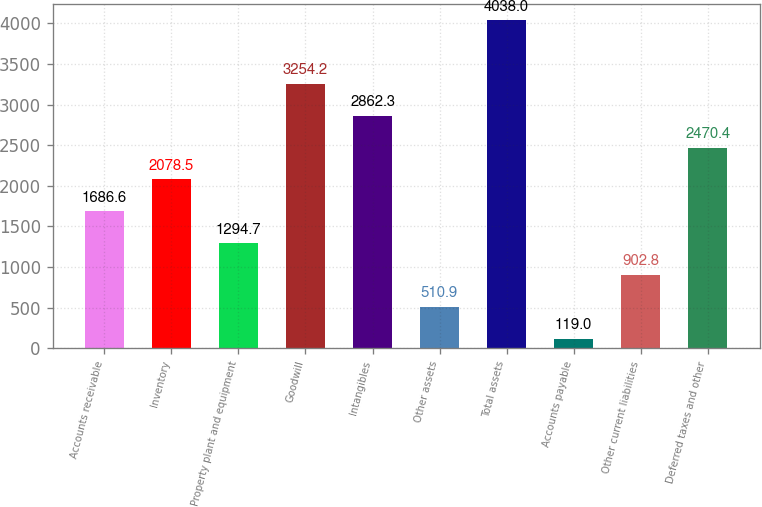<chart> <loc_0><loc_0><loc_500><loc_500><bar_chart><fcel>Accounts receivable<fcel>Inventory<fcel>Property plant and equipment<fcel>Goodwill<fcel>Intangibles<fcel>Other assets<fcel>Total assets<fcel>Accounts payable<fcel>Other current liabilities<fcel>Deferred taxes and other<nl><fcel>1686.6<fcel>2078.5<fcel>1294.7<fcel>3254.2<fcel>2862.3<fcel>510.9<fcel>4038<fcel>119<fcel>902.8<fcel>2470.4<nl></chart> 